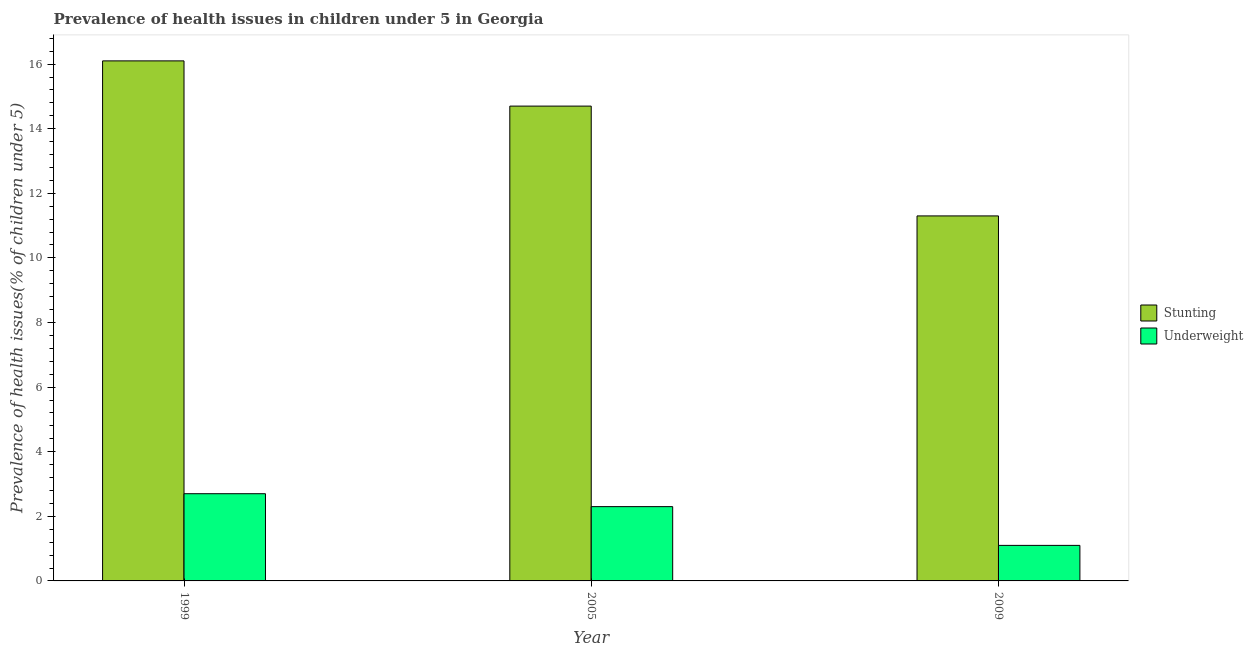How many groups of bars are there?
Ensure brevity in your answer.  3. Are the number of bars per tick equal to the number of legend labels?
Offer a terse response. Yes. What is the percentage of stunted children in 2009?
Your response must be concise. 11.3. Across all years, what is the maximum percentage of stunted children?
Ensure brevity in your answer.  16.1. Across all years, what is the minimum percentage of underweight children?
Ensure brevity in your answer.  1.1. In which year was the percentage of stunted children maximum?
Ensure brevity in your answer.  1999. In which year was the percentage of underweight children minimum?
Ensure brevity in your answer.  2009. What is the total percentage of stunted children in the graph?
Your answer should be compact. 42.1. What is the difference between the percentage of underweight children in 2005 and that in 2009?
Your response must be concise. 1.2. What is the difference between the percentage of stunted children in 2005 and the percentage of underweight children in 1999?
Make the answer very short. -1.4. What is the average percentage of underweight children per year?
Your response must be concise. 2.03. In how many years, is the percentage of stunted children greater than 12 %?
Offer a very short reply. 2. What is the ratio of the percentage of stunted children in 1999 to that in 2009?
Keep it short and to the point. 1.42. Is the percentage of stunted children in 1999 less than that in 2009?
Offer a terse response. No. Is the difference between the percentage of stunted children in 1999 and 2005 greater than the difference between the percentage of underweight children in 1999 and 2005?
Provide a succinct answer. No. What is the difference between the highest and the second highest percentage of underweight children?
Make the answer very short. 0.4. What is the difference between the highest and the lowest percentage of underweight children?
Your answer should be very brief. 1.6. In how many years, is the percentage of underweight children greater than the average percentage of underweight children taken over all years?
Your answer should be compact. 2. What does the 1st bar from the left in 2009 represents?
Your response must be concise. Stunting. What does the 2nd bar from the right in 2009 represents?
Offer a terse response. Stunting. How many bars are there?
Make the answer very short. 6. Are the values on the major ticks of Y-axis written in scientific E-notation?
Keep it short and to the point. No. Does the graph contain grids?
Make the answer very short. No. Where does the legend appear in the graph?
Provide a succinct answer. Center right. How many legend labels are there?
Offer a very short reply. 2. What is the title of the graph?
Make the answer very short. Prevalence of health issues in children under 5 in Georgia. What is the label or title of the Y-axis?
Ensure brevity in your answer.  Prevalence of health issues(% of children under 5). What is the Prevalence of health issues(% of children under 5) in Stunting in 1999?
Make the answer very short. 16.1. What is the Prevalence of health issues(% of children under 5) in Underweight in 1999?
Provide a succinct answer. 2.7. What is the Prevalence of health issues(% of children under 5) of Stunting in 2005?
Offer a terse response. 14.7. What is the Prevalence of health issues(% of children under 5) of Underweight in 2005?
Give a very brief answer. 2.3. What is the Prevalence of health issues(% of children under 5) of Stunting in 2009?
Offer a terse response. 11.3. What is the Prevalence of health issues(% of children under 5) of Underweight in 2009?
Your answer should be very brief. 1.1. Across all years, what is the maximum Prevalence of health issues(% of children under 5) in Stunting?
Your response must be concise. 16.1. Across all years, what is the maximum Prevalence of health issues(% of children under 5) of Underweight?
Give a very brief answer. 2.7. Across all years, what is the minimum Prevalence of health issues(% of children under 5) of Stunting?
Ensure brevity in your answer.  11.3. Across all years, what is the minimum Prevalence of health issues(% of children under 5) in Underweight?
Give a very brief answer. 1.1. What is the total Prevalence of health issues(% of children under 5) in Stunting in the graph?
Your answer should be very brief. 42.1. What is the total Prevalence of health issues(% of children under 5) of Underweight in the graph?
Make the answer very short. 6.1. What is the difference between the Prevalence of health issues(% of children under 5) in Stunting in 2005 and that in 2009?
Give a very brief answer. 3.4. What is the difference between the Prevalence of health issues(% of children under 5) of Underweight in 2005 and that in 2009?
Provide a short and direct response. 1.2. What is the difference between the Prevalence of health issues(% of children under 5) of Stunting in 1999 and the Prevalence of health issues(% of children under 5) of Underweight in 2005?
Your response must be concise. 13.8. What is the difference between the Prevalence of health issues(% of children under 5) of Stunting in 1999 and the Prevalence of health issues(% of children under 5) of Underweight in 2009?
Keep it short and to the point. 15. What is the difference between the Prevalence of health issues(% of children under 5) in Stunting in 2005 and the Prevalence of health issues(% of children under 5) in Underweight in 2009?
Your answer should be compact. 13.6. What is the average Prevalence of health issues(% of children under 5) in Stunting per year?
Give a very brief answer. 14.03. What is the average Prevalence of health issues(% of children under 5) in Underweight per year?
Offer a terse response. 2.03. In the year 1999, what is the difference between the Prevalence of health issues(% of children under 5) of Stunting and Prevalence of health issues(% of children under 5) of Underweight?
Your answer should be very brief. 13.4. What is the ratio of the Prevalence of health issues(% of children under 5) of Stunting in 1999 to that in 2005?
Offer a very short reply. 1.1. What is the ratio of the Prevalence of health issues(% of children under 5) in Underweight in 1999 to that in 2005?
Ensure brevity in your answer.  1.17. What is the ratio of the Prevalence of health issues(% of children under 5) in Stunting in 1999 to that in 2009?
Offer a terse response. 1.42. What is the ratio of the Prevalence of health issues(% of children under 5) in Underweight in 1999 to that in 2009?
Provide a succinct answer. 2.45. What is the ratio of the Prevalence of health issues(% of children under 5) in Stunting in 2005 to that in 2009?
Offer a very short reply. 1.3. What is the ratio of the Prevalence of health issues(% of children under 5) in Underweight in 2005 to that in 2009?
Ensure brevity in your answer.  2.09. What is the difference between the highest and the lowest Prevalence of health issues(% of children under 5) of Stunting?
Ensure brevity in your answer.  4.8. 